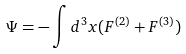Convert formula to latex. <formula><loc_0><loc_0><loc_500><loc_500>\Psi = - \int d ^ { 3 } x ( F ^ { ( 2 ) } + F ^ { ( 3 ) } )</formula> 